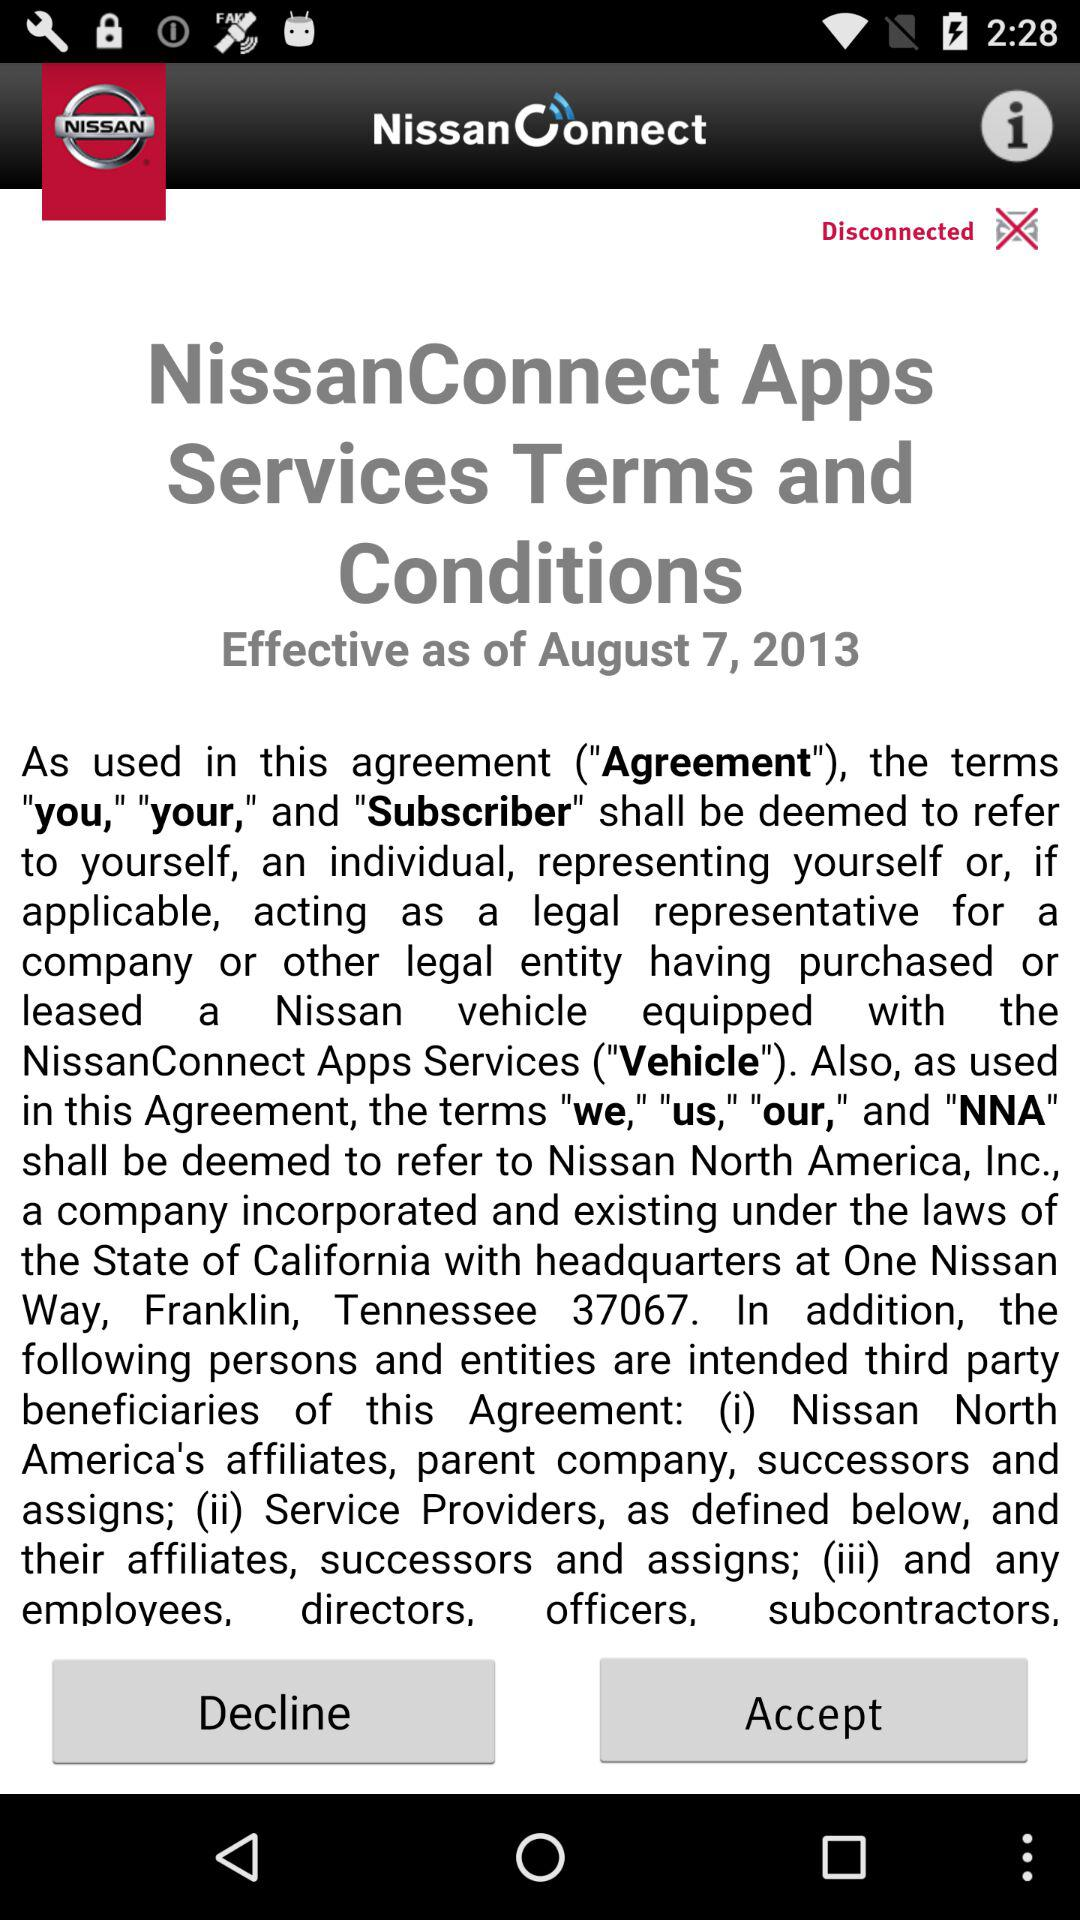What is the date? The date is August 7, 2013. 